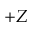<formula> <loc_0><loc_0><loc_500><loc_500>+ Z</formula> 